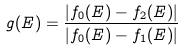Convert formula to latex. <formula><loc_0><loc_0><loc_500><loc_500>g ( E ) = \frac { | f _ { 0 } ( E ) - f _ { 2 } ( E ) | } { | f _ { 0 } ( E ) - f _ { 1 } ( E ) | }</formula> 